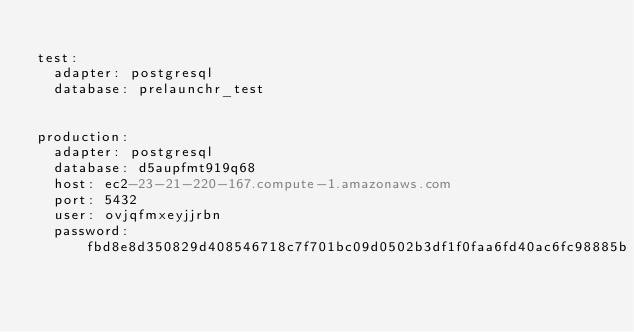Convert code to text. <code><loc_0><loc_0><loc_500><loc_500><_YAML_>
test:
  adapter: postgresql
  database: prelaunchr_test
 

production:
  adapter: postgresql
  database: d5aupfmt919q68
  host: ec2-23-21-220-167.compute-1.amazonaws.com
  port: 5432
  user: ovjqfmxeyjjrbn
  password: fbd8e8d350829d408546718c7f701bc09d0502b3df1f0faa6fd40ac6fc98885b
</code> 